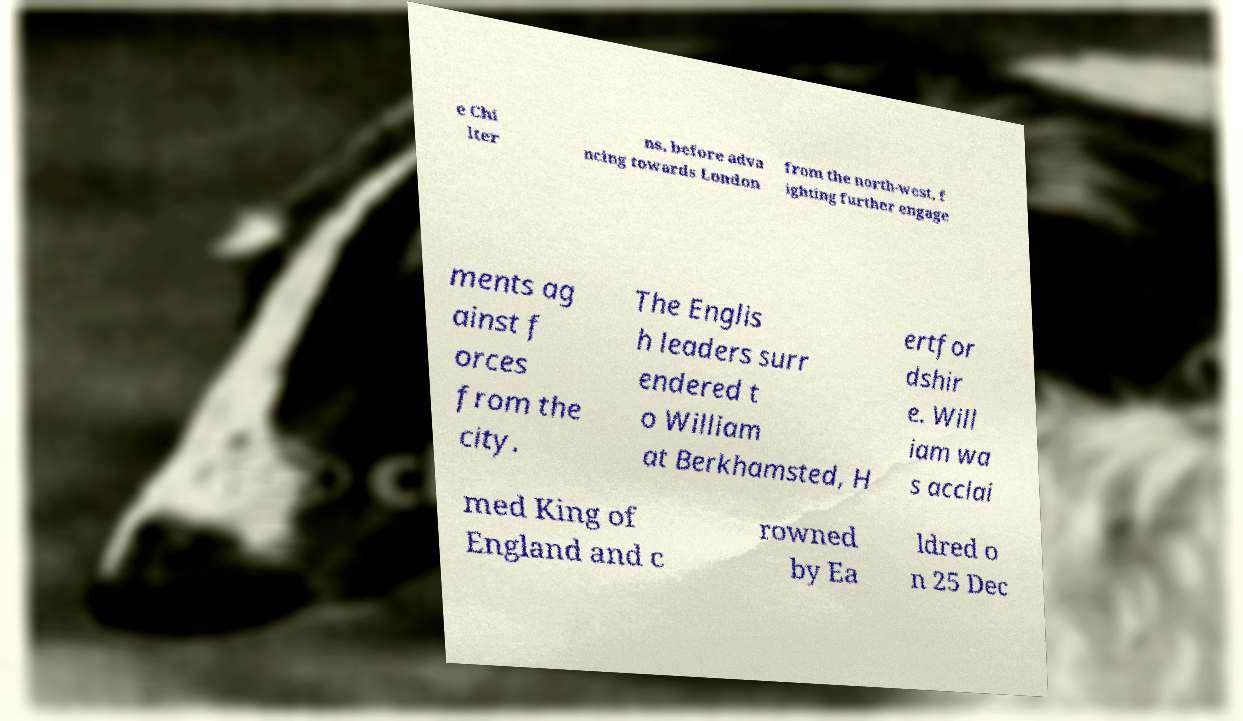Please identify and transcribe the text found in this image. e Chi lter ns, before adva ncing towards London from the north-west, f ighting further engage ments ag ainst f orces from the city. The Englis h leaders surr endered t o William at Berkhamsted, H ertfor dshir e. Will iam wa s acclai med King of England and c rowned by Ea ldred o n 25 Dec 